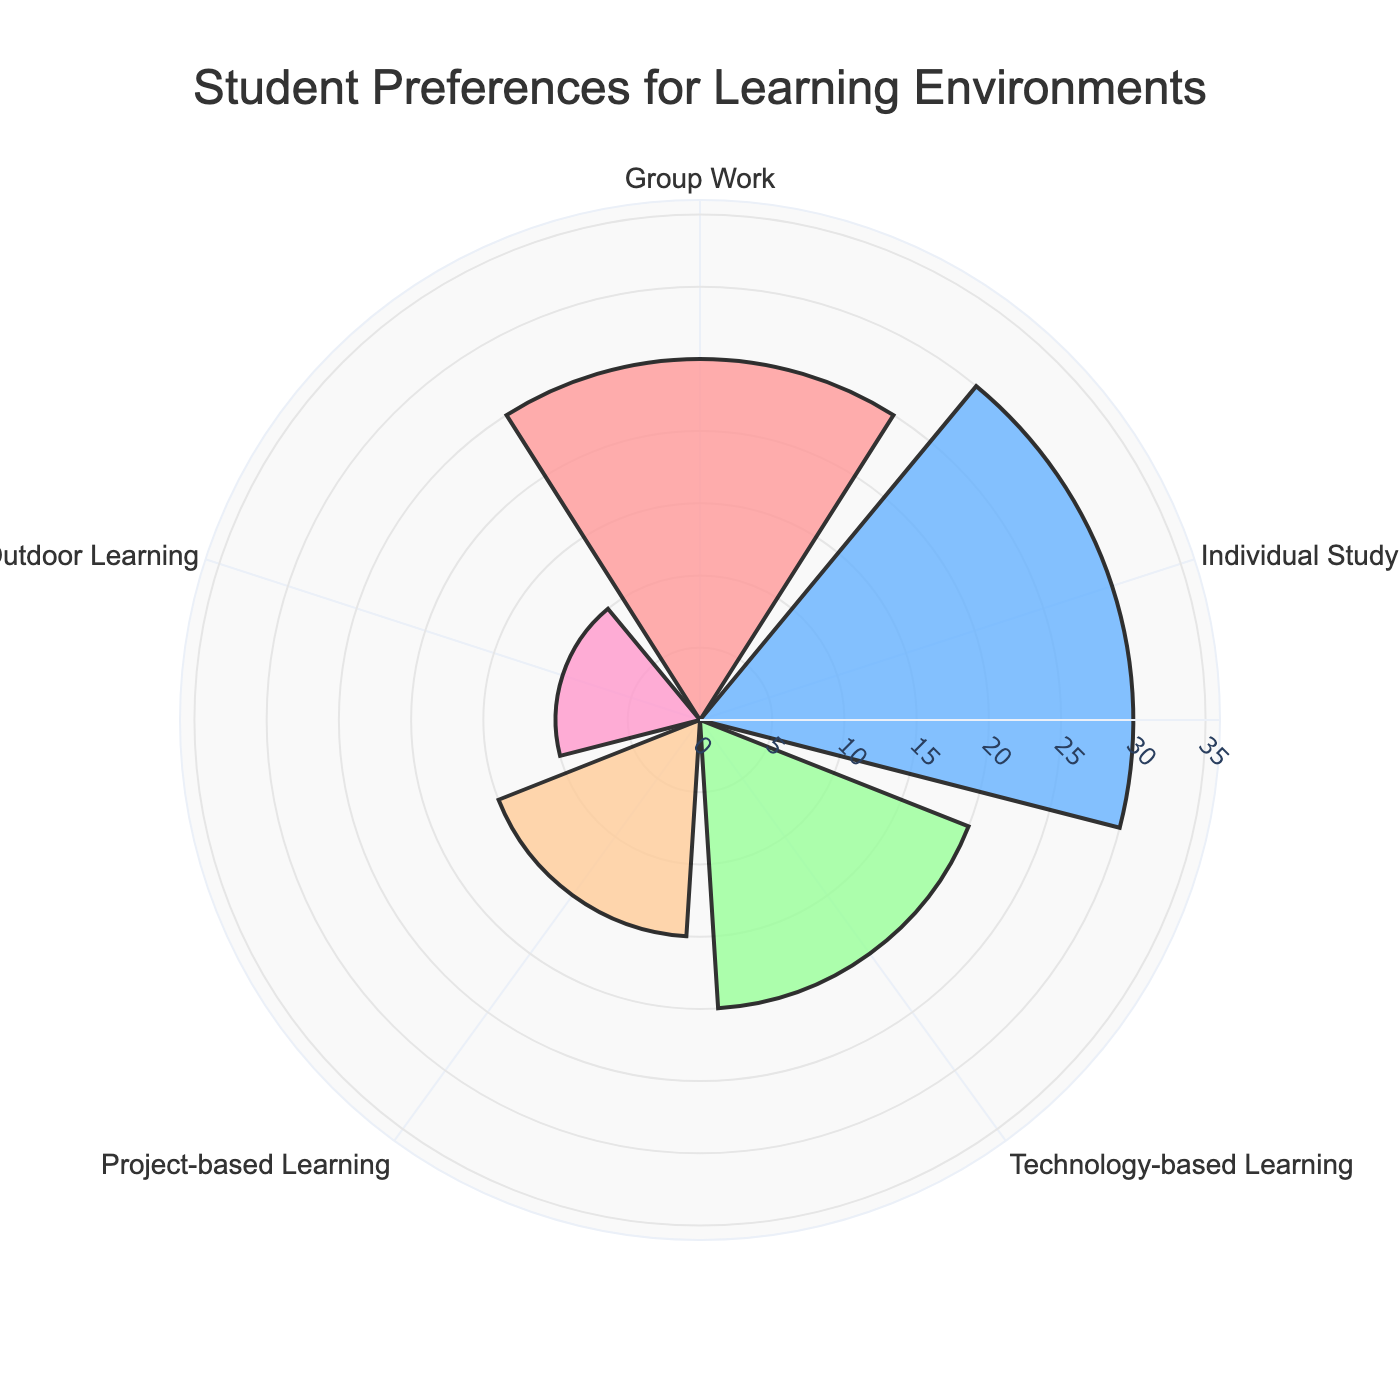What is the title of the figure? The title of the figure is usually positioned at the top of the chart. In this figure, it is located at the top center.
Answer: Student Preferences for Learning Environments What learning environment has the highest percentage? By looking at the length of the bars, the one with the obvious maximum length corresponds to the learning environment category "Individual Study".
Answer: Individual Study Compare Group Work and Project-based Learning. Which one has a higher preference? Compare the lengths of the bars for "Group Work" and "Project-based Learning". The bar for "Group Work" is longer than that of "Project-based Learning".
Answer: Group Work What is the combined percentage of Technology-based Learning and Outdoor Learning? Add the percentages of Technology-based Learning (20%) and Outdoor Learning (10%). The combined percentage is 20 + 10 = 30%.
Answer: 30% Which learning environment is the least preferred by students? The shortest bar indicates the least preferred learning environment. In this case, it's "Outdoor Learning".
Answer: Outdoor Learning How much more do students prefer Individual Study over Technology-based Learning? Subtract the percentage of Technology-based Learning (20%) from the percentage of Individual Study (30%). The difference is 30 - 20 = 10%.
Answer: 10% What are the colors used for Group Work and Project-based Learning? Group Work is colored light pink, while Project-based Learning is colored light orange.
Answer: light pink and light orange Calculate the average percentage preference across all learning environments. Sum the percentages of all learning environments (25 + 30 + 20 + 15 + 10) = 100. Divide by the number of categories, which is 5. The average percentage is 100 / 5 = 20%.
Answer: 20% If you were to recommend one learning environment to be prioritized based on the chart, which one would it be? The recommendation should be based on the highest percentage. In this chart, "Individual Study" has the highest preference at 30%.
Answer: Individual Study 